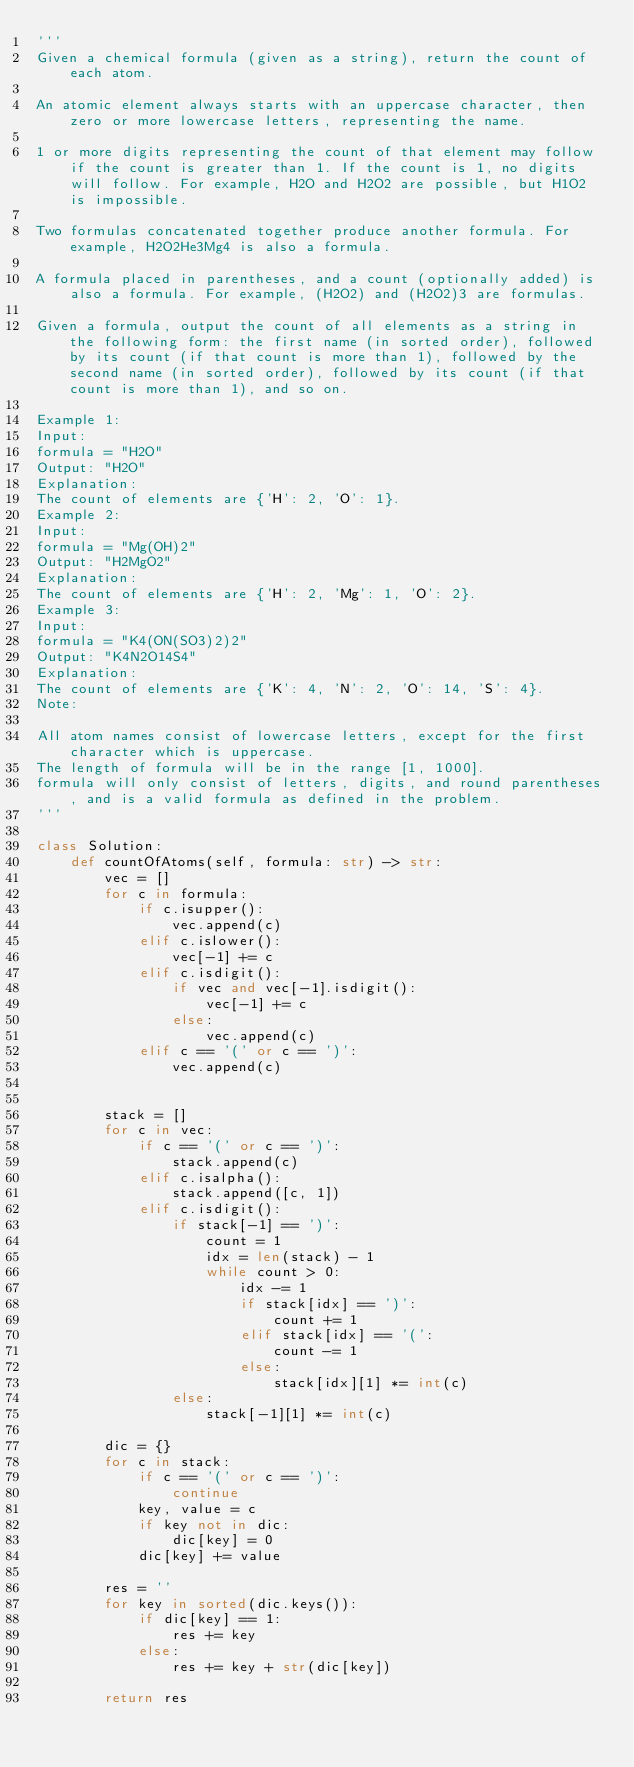Convert code to text. <code><loc_0><loc_0><loc_500><loc_500><_Python_>'''
Given a chemical formula (given as a string), return the count of each atom.

An atomic element always starts with an uppercase character, then zero or more lowercase letters, representing the name.

1 or more digits representing the count of that element may follow if the count is greater than 1. If the count is 1, no digits will follow. For example, H2O and H2O2 are possible, but H1O2 is impossible.

Two formulas concatenated together produce another formula. For example, H2O2He3Mg4 is also a formula.

A formula placed in parentheses, and a count (optionally added) is also a formula. For example, (H2O2) and (H2O2)3 are formulas.

Given a formula, output the count of all elements as a string in the following form: the first name (in sorted order), followed by its count (if that count is more than 1), followed by the second name (in sorted order), followed by its count (if that count is more than 1), and so on.

Example 1:
Input: 
formula = "H2O"
Output: "H2O"
Explanation: 
The count of elements are {'H': 2, 'O': 1}.
Example 2:
Input: 
formula = "Mg(OH)2"
Output: "H2MgO2"
Explanation: 
The count of elements are {'H': 2, 'Mg': 1, 'O': 2}.
Example 3:
Input: 
formula = "K4(ON(SO3)2)2"
Output: "K4N2O14S4"
Explanation: 
The count of elements are {'K': 4, 'N': 2, 'O': 14, 'S': 4}.
Note:

All atom names consist of lowercase letters, except for the first character which is uppercase.
The length of formula will be in the range [1, 1000].
formula will only consist of letters, digits, and round parentheses, and is a valid formula as defined in the problem.
'''

class Solution:
    def countOfAtoms(self, formula: str) -> str:
        vec = []
        for c in formula:
            if c.isupper():
                vec.append(c)
            elif c.islower():
                vec[-1] += c
            elif c.isdigit():
                if vec and vec[-1].isdigit():
                    vec[-1] += c
                else:
                    vec.append(c)
            elif c == '(' or c == ')':
                vec.append(c)
                

        stack = []
        for c in vec:
            if c == '(' or c == ')':
                stack.append(c)
            elif c.isalpha():
                stack.append([c, 1])
            elif c.isdigit():
                if stack[-1] == ')':
                    count = 1
                    idx = len(stack) - 1
                    while count > 0:
                        idx -= 1
                        if stack[idx] == ')':
                            count += 1
                        elif stack[idx] == '(':
                            count -= 1
                        else:
                            stack[idx][1] *= int(c)
                else:
                    stack[-1][1] *= int(c)
        
        dic = {}
        for c in stack:
            if c == '(' or c == ')':
                continue
            key, value = c
            if key not in dic:
                dic[key] = 0
            dic[key] += value
        
        res = ''
        for key in sorted(dic.keys()):
            if dic[key] == 1:
                res += key
            else:
                res += key + str(dic[key])
        
        return res
        
</code> 